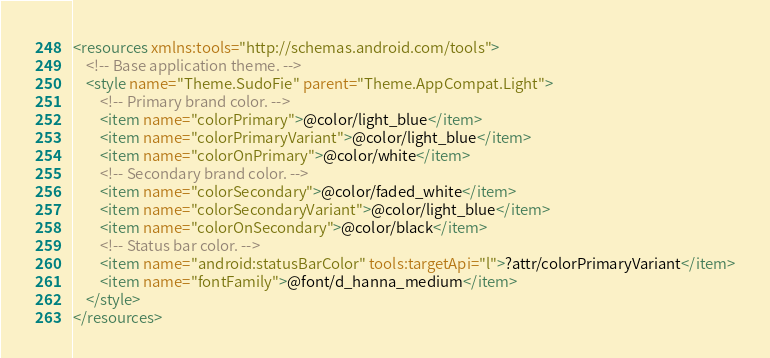<code> <loc_0><loc_0><loc_500><loc_500><_XML_><resources xmlns:tools="http://schemas.android.com/tools">
    <!-- Base application theme. -->
    <style name="Theme.SudoFie" parent="Theme.AppCompat.Light">
        <!-- Primary brand color. -->
        <item name="colorPrimary">@color/light_blue</item>
        <item name="colorPrimaryVariant">@color/light_blue</item>
        <item name="colorOnPrimary">@color/white</item>
        <!-- Secondary brand color. -->
        <item name="colorSecondary">@color/faded_white</item>
        <item name="colorSecondaryVariant">@color/light_blue</item>
        <item name="colorOnSecondary">@color/black</item>
        <!-- Status bar color. -->
        <item name="android:statusBarColor" tools:targetApi="l">?attr/colorPrimaryVariant</item>
        <item name="fontFamily">@font/d_hanna_medium</item>
    </style>
</resources></code> 